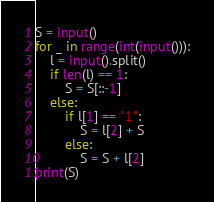Convert code to text. <code><loc_0><loc_0><loc_500><loc_500><_Python_>S = input()
for _ in range(int(input())):
    l = input().split()
    if len(l) == 1:
        S = S[::-1]
    else:
        if l[1] == "1":
            S = l[2] + S
        else:
            S = S + l[2]
print(S)</code> 